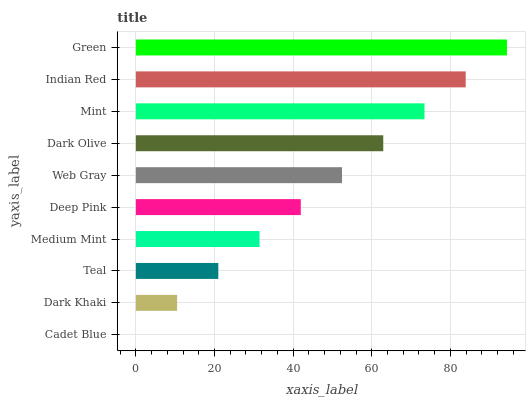Is Cadet Blue the minimum?
Answer yes or no. Yes. Is Green the maximum?
Answer yes or no. Yes. Is Dark Khaki the minimum?
Answer yes or no. No. Is Dark Khaki the maximum?
Answer yes or no. No. Is Dark Khaki greater than Cadet Blue?
Answer yes or no. Yes. Is Cadet Blue less than Dark Khaki?
Answer yes or no. Yes. Is Cadet Blue greater than Dark Khaki?
Answer yes or no. No. Is Dark Khaki less than Cadet Blue?
Answer yes or no. No. Is Web Gray the high median?
Answer yes or no. Yes. Is Deep Pink the low median?
Answer yes or no. Yes. Is Cadet Blue the high median?
Answer yes or no. No. Is Dark Khaki the low median?
Answer yes or no. No. 